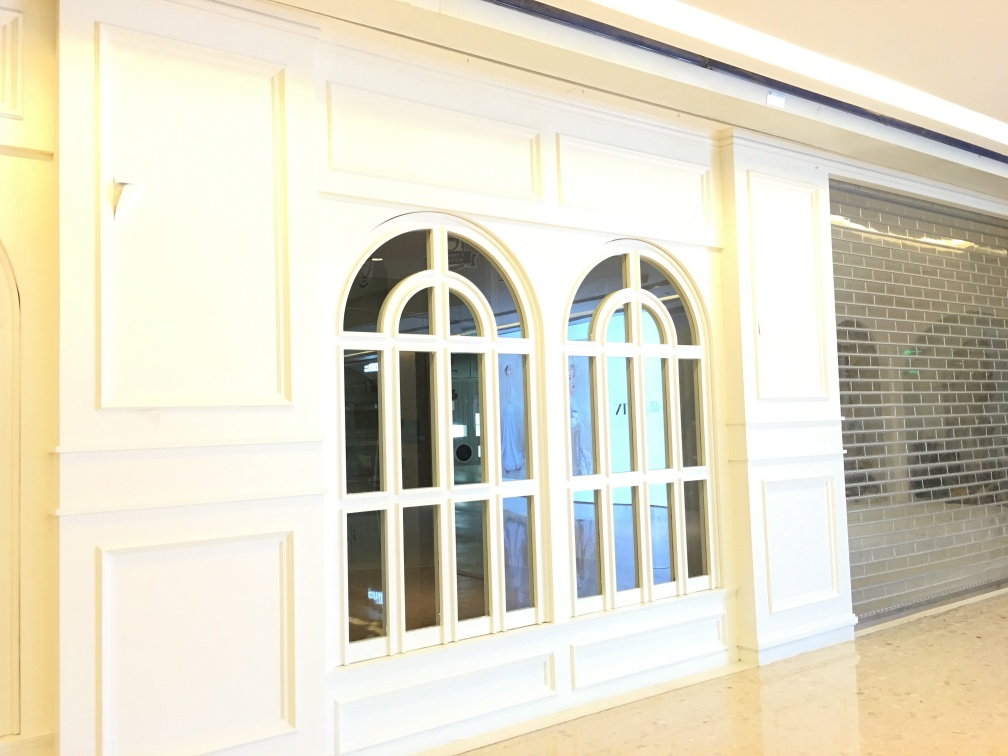What style of architecture do the windows represent? The windows have a rounded arch at the top, a feature commonly seen in Romanesque architecture. However, the simplicity of the design also suggests some influence from contemporary styles, aiming for a clean and uncluttered aesthetic. 